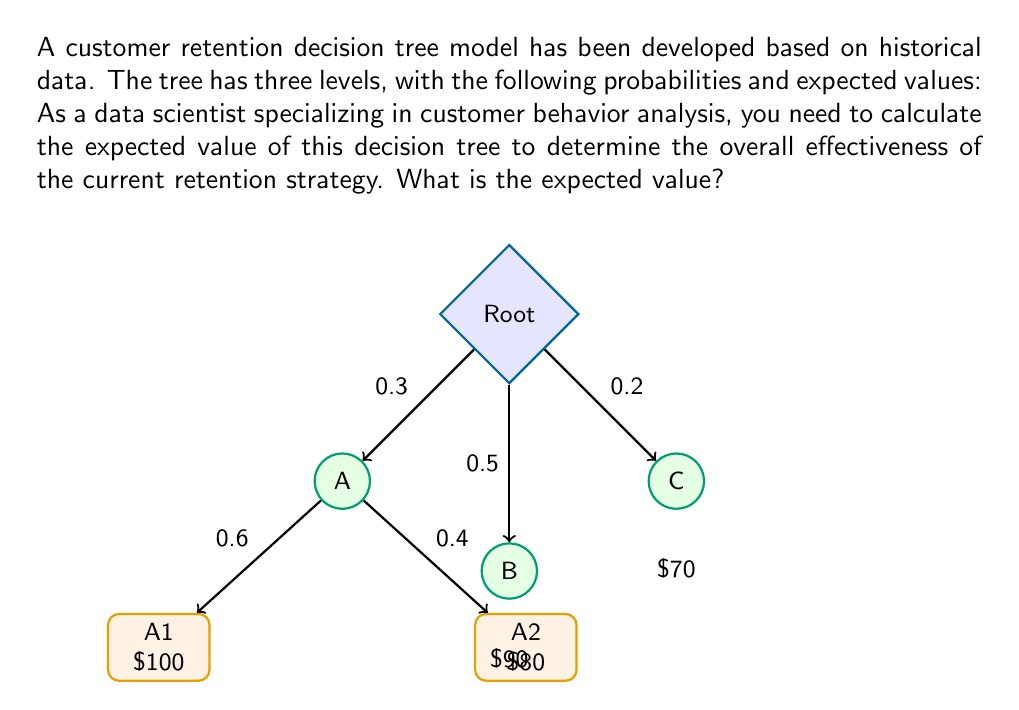Could you help me with this problem? To calculate the expected value of the decision tree, we need to work from the bottom up, considering the probabilities and values at each level.

Step 1: Calculate the expected value for branch A
$$EV(A) = 0.6 \times \$100 + 0.4 \times \$80 = \$60 + \$32 = \$92$$

Step 2: Consider the expected values for all branches at the second level
- Branch A: $92 (calculated in step 1)
- Branch B: $90 (given)
- Branch C: $70 (given)

Step 3: Calculate the overall expected value using the probabilities from the root node
$$EV(\text{Root}) = 0.3 \times \$92 + 0.5 \times \$90 + 0.2 \times \$70$$

Step 4: Compute the final result
$$EV(\text{Root}) = \$27.60 + \$45.00 + \$14.00 = \$86.60$$

Therefore, the expected value of the decision tree, representing the overall effectiveness of the current retention strategy, is $86.60.
Answer: $86.60 